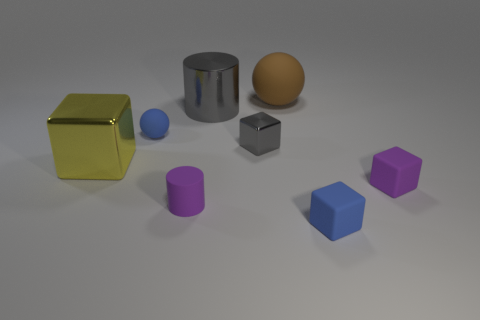There is a brown thing; what number of tiny cubes are right of it?
Ensure brevity in your answer.  2. What number of blue objects are matte things or big metal objects?
Your response must be concise. 2. What is the material of the cylinder that is the same size as the blue block?
Your answer should be compact. Rubber. What is the shape of the metallic thing that is on the left side of the tiny gray thing and to the right of the big block?
Your response must be concise. Cylinder. The shiny block that is the same size as the purple rubber cylinder is what color?
Your answer should be very brief. Gray. There is a blue rubber thing behind the tiny purple block; does it have the same size as the blue rubber thing that is on the right side of the large brown thing?
Your answer should be compact. Yes. There is a matte ball that is on the right side of the small blue rubber thing that is behind the small purple cube in front of the large matte object; what is its size?
Your answer should be compact. Large. There is a small blue rubber thing that is in front of the blue thing to the left of the big matte ball; what is its shape?
Provide a succinct answer. Cube. Does the metallic block that is on the left side of the small purple cylinder have the same color as the small shiny thing?
Your response must be concise. No. There is a tiny rubber object that is both on the left side of the tiny gray metallic cube and in front of the small gray block; what color is it?
Make the answer very short. Purple. 